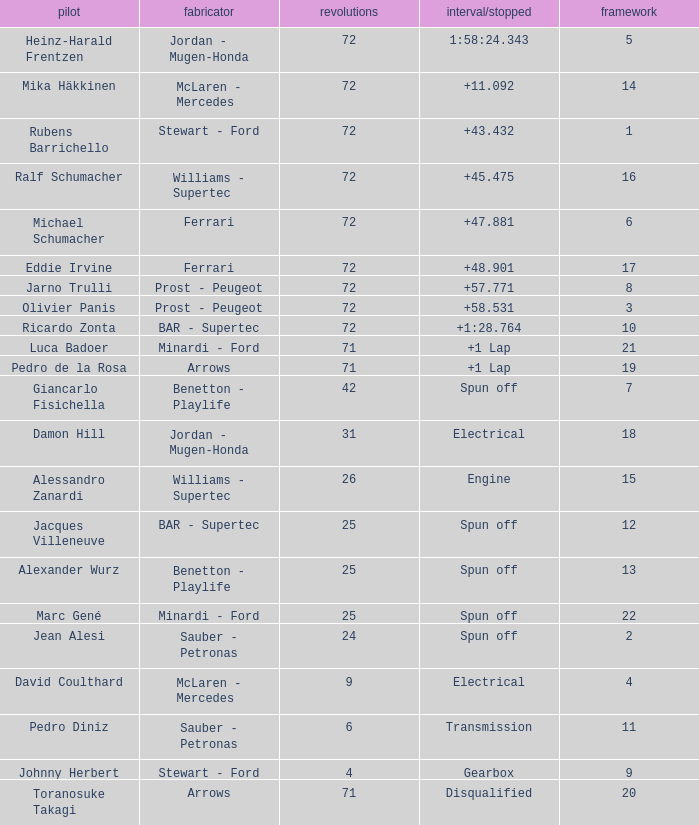What was Alexander Wurz's highest grid with laps of less than 25? None. 